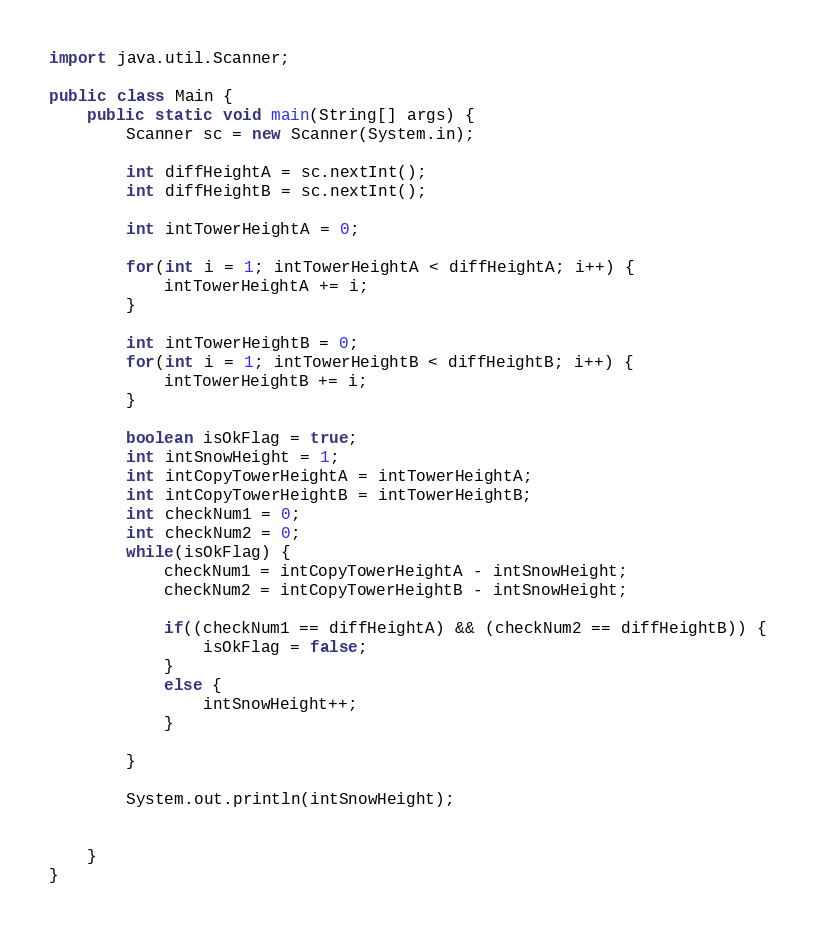Convert code to text. <code><loc_0><loc_0><loc_500><loc_500><_Java_>
import java.util.Scanner;

public class Main {
	public static void main(String[] args) {
		Scanner sc = new Scanner(System.in);

		int diffHeightA = sc.nextInt();
		int diffHeightB = sc.nextInt();

		int intTowerHeightA = 0;

		for(int i = 1; intTowerHeightA < diffHeightA; i++) {
			intTowerHeightA += i;
		}

		int intTowerHeightB = 0;
		for(int i = 1; intTowerHeightB < diffHeightB; i++) {
			intTowerHeightB += i;
		}

		boolean isOkFlag = true;
		int intSnowHeight = 1;
		int intCopyTowerHeightA = intTowerHeightA;
		int intCopyTowerHeightB = intTowerHeightB;
		int checkNum1 = 0;
		int checkNum2 = 0;
		while(isOkFlag) {
			checkNum1 = intCopyTowerHeightA - intSnowHeight;
			checkNum2 = intCopyTowerHeightB - intSnowHeight;

			if((checkNum1 == diffHeightA) && (checkNum2 == diffHeightB)) {
				isOkFlag = false;
			}
			else {
				intSnowHeight++;
			}

		}

		System.out.println(intSnowHeight);


	}
}</code> 